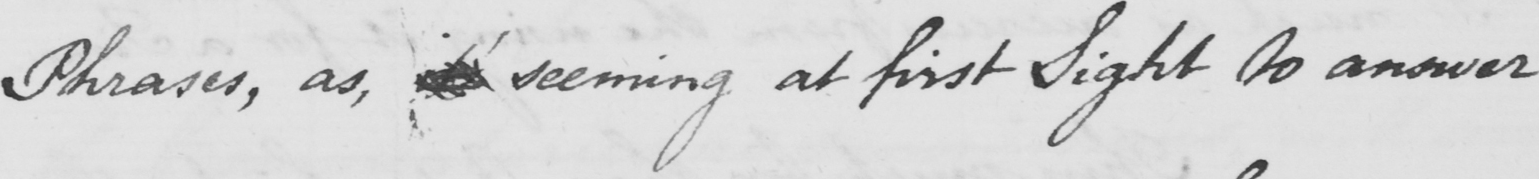Please provide the text content of this handwritten line. Phrases , as , seeming at first Sight to answer 